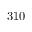<formula> <loc_0><loc_0><loc_500><loc_500>3 1 0</formula> 